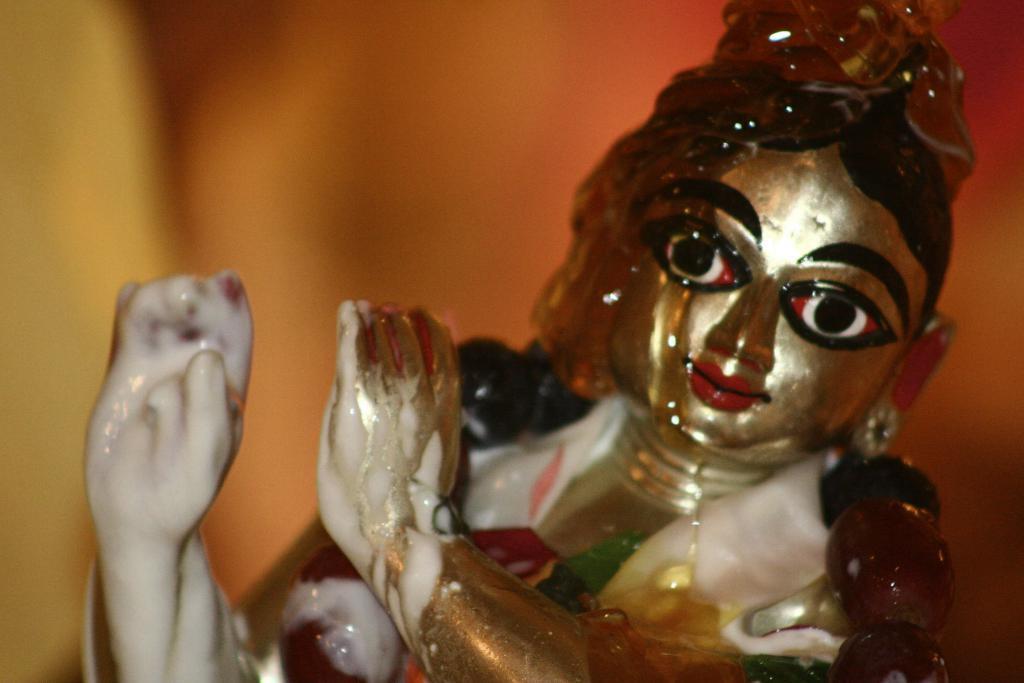Please provide a concise description of this image. In this image we can see an idol. In the background it is blur. 